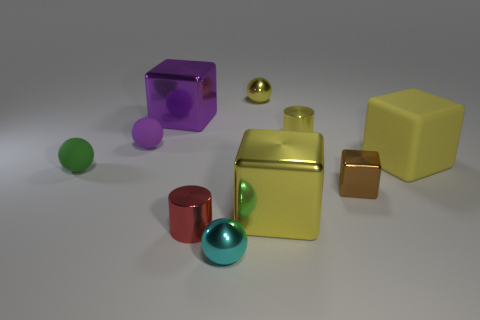What number of yellow cylinders are there?
Offer a terse response. 1. There is a metal cylinder that is to the right of the tiny cyan ball; does it have the same color as the tiny sphere behind the small purple matte object?
Ensure brevity in your answer.  Yes. What is the size of the cube that is the same color as the big matte object?
Ensure brevity in your answer.  Large. How many other things are there of the same size as the yellow metallic cylinder?
Provide a short and direct response. 6. There is a metal cube behind the yellow rubber object; what is its color?
Give a very brief answer. Purple. Do the large block on the left side of the cyan sphere and the purple ball have the same material?
Your answer should be compact. No. What number of objects are to the left of the small yellow shiny ball and right of the green ball?
Keep it short and to the point. 4. What is the color of the metal ball that is behind the tiny green thing that is behind the large yellow cube to the left of the brown shiny block?
Your answer should be compact. Yellow. How many other things are there of the same shape as the large yellow rubber object?
Ensure brevity in your answer.  3. Is there a tiny shiny thing left of the ball that is behind the purple metallic object?
Give a very brief answer. Yes. 